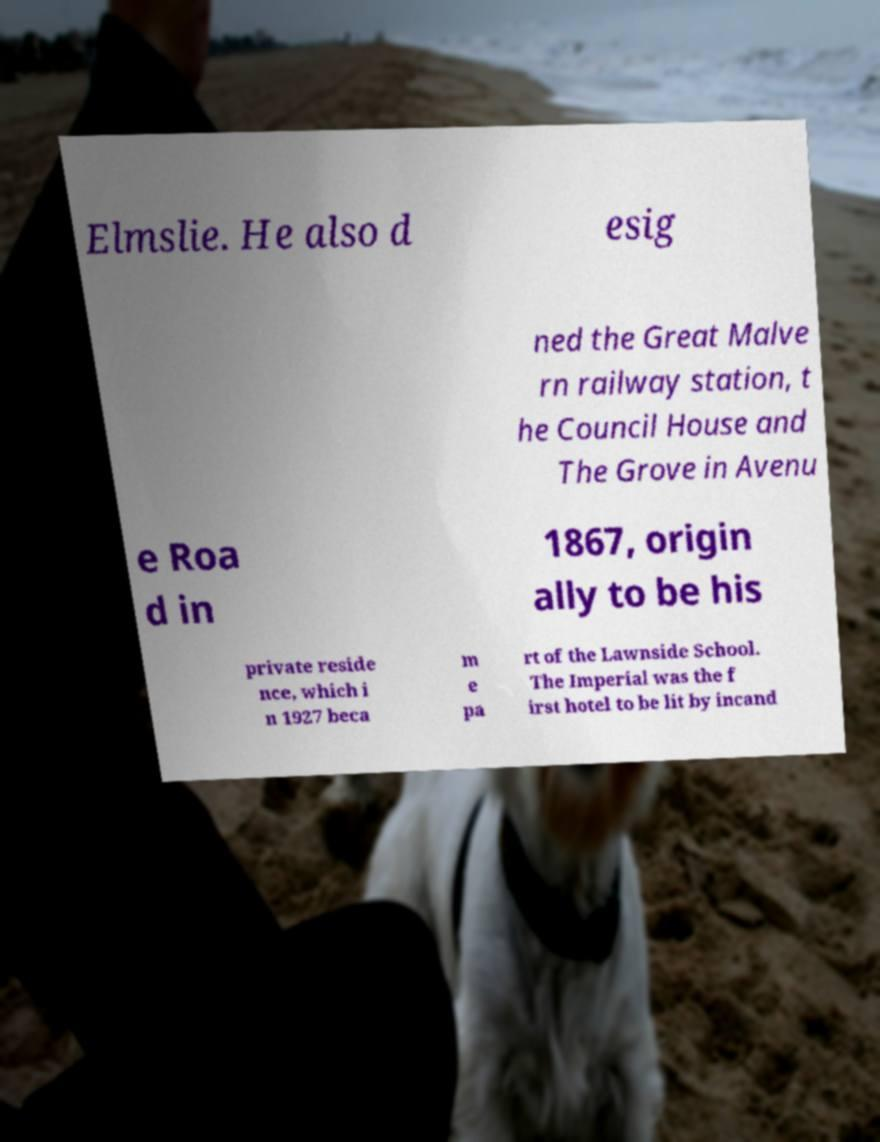Could you extract and type out the text from this image? Elmslie. He also d esig ned the Great Malve rn railway station, t he Council House and The Grove in Avenu e Roa d in 1867, origin ally to be his private reside nce, which i n 1927 beca m e pa rt of the Lawnside School. The Imperial was the f irst hotel to be lit by incand 